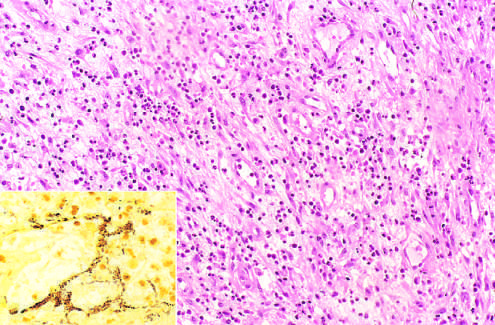does the inner core of tan tissue demonstrate clusters of tangled bacilli (black)?
Answer the question using a single word or phrase. No 